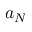<formula> <loc_0><loc_0><loc_500><loc_500>a _ { N }</formula> 